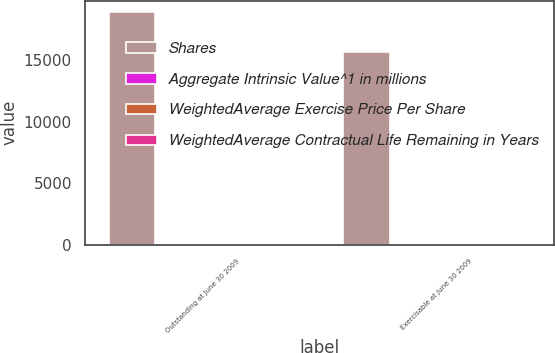<chart> <loc_0><loc_0><loc_500><loc_500><stacked_bar_chart><ecel><fcel>Outstanding at June 30 2009<fcel>Exercisable at June 30 2009<nl><fcel>Shares<fcel>18914.7<fcel>15647<nl><fcel>Aggregate Intrinsic Value^1 in millions<fcel>43.5<fcel>42.7<nl><fcel>WeightedAverage Exercise Price Per Share<fcel>1.9<fcel>1.9<nl><fcel>WeightedAverage Contractual Life Remaining in Years<fcel>3.8<fcel>2.8<nl></chart> 